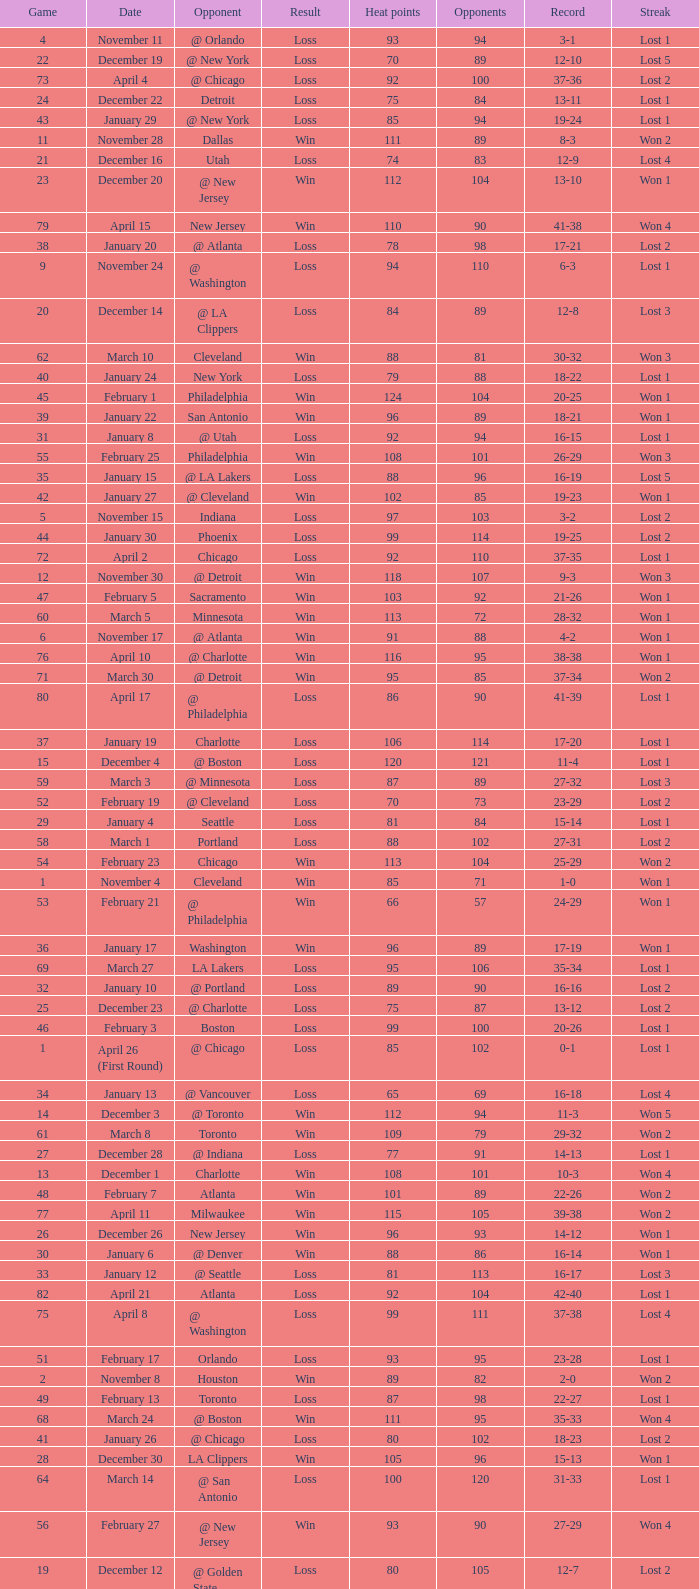What is the highest Game, when Opponents is less than 80, and when Record is "1-0"? 1.0. 